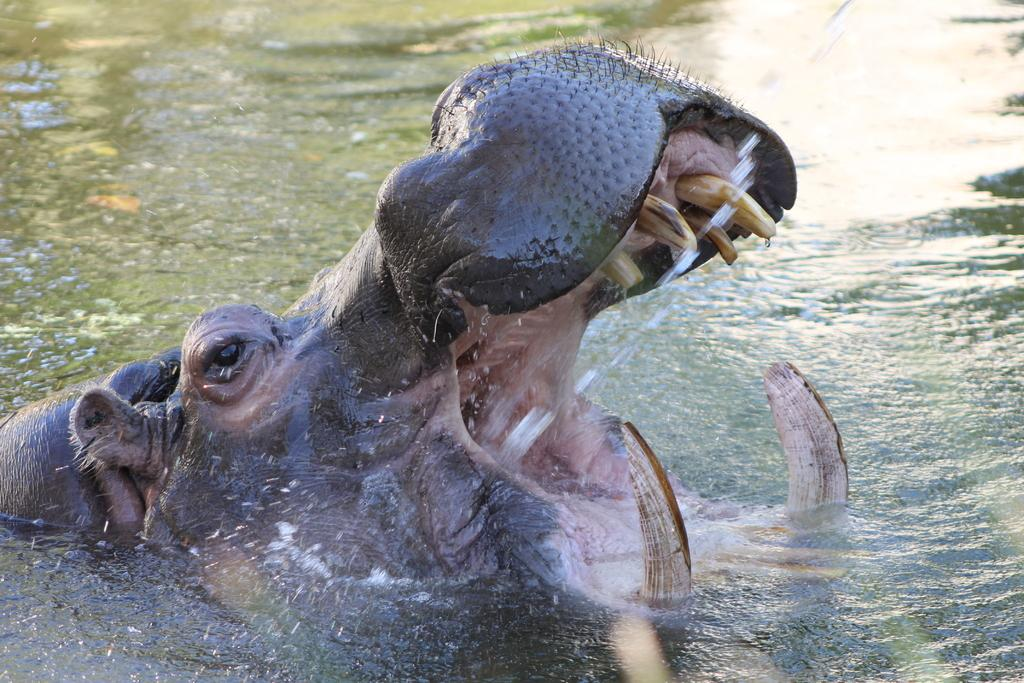What animal is present in the image? There is a hippopotamus in the image. Where is the hippopotamus located? The hippopotamus is in the water. What type of environment is depicted in the image? The image contains water. How much money is the hippopotamus holding in the image? There is no money present in the image, as it features a hippopotamus in the water. 